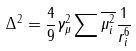<formula> <loc_0><loc_0><loc_500><loc_500>\Delta ^ { 2 } = \frac { 4 } { 9 } \gamma _ { \mu } ^ { 2 } \sum \overline { \mu _ { i } ^ { 2 } } \frac { 1 } { r _ { i } ^ { 6 } }</formula> 